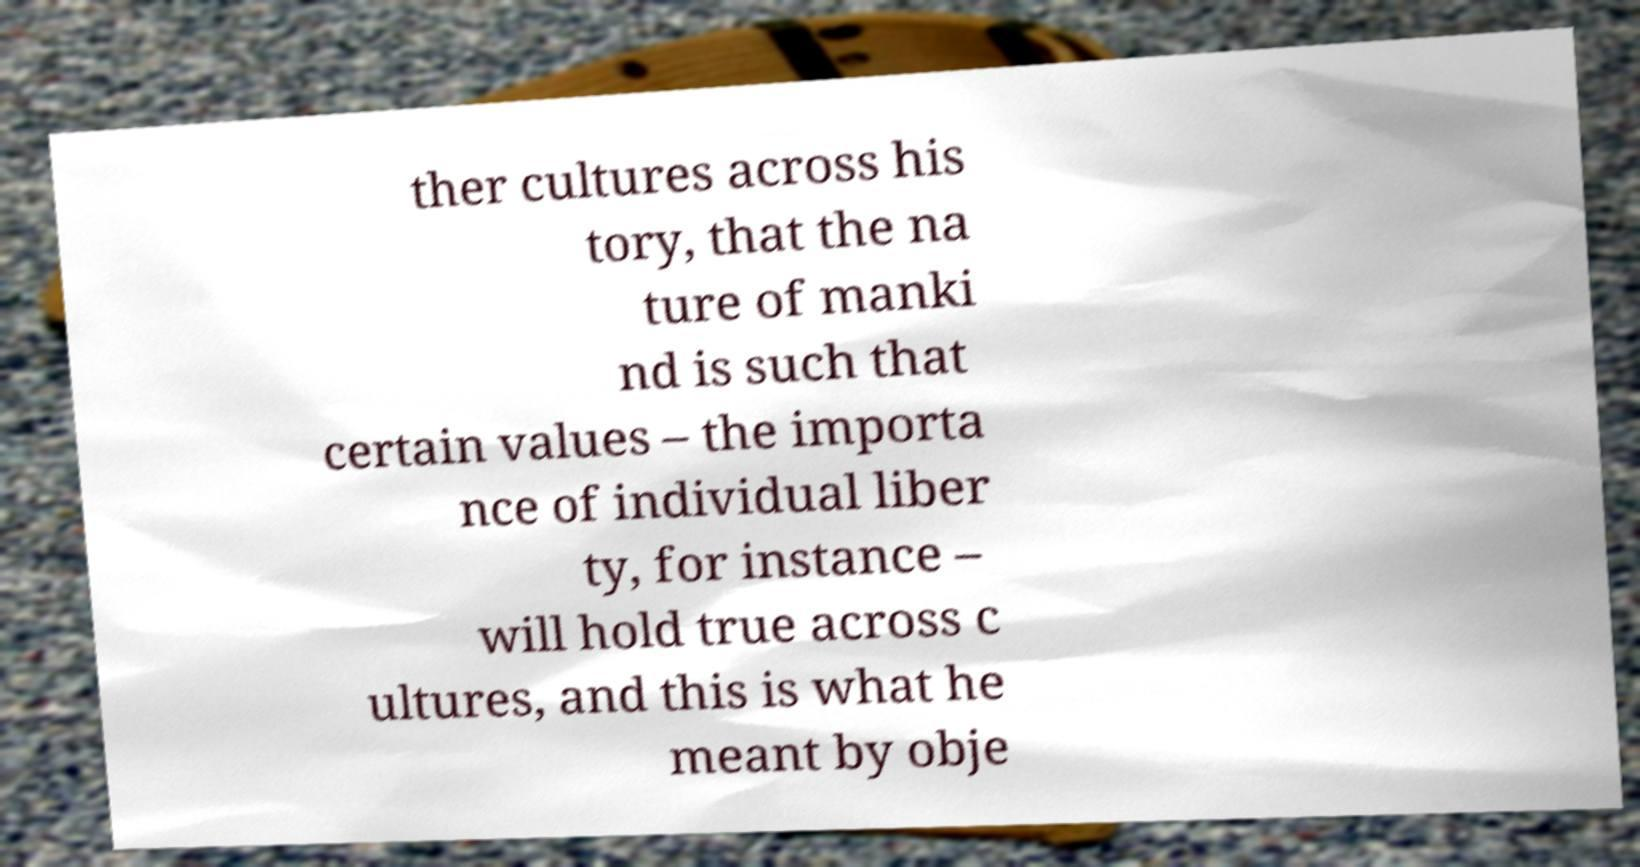What messages or text are displayed in this image? I need them in a readable, typed format. ther cultures across his tory, that the na ture of manki nd is such that certain values – the importa nce of individual liber ty, for instance – will hold true across c ultures, and this is what he meant by obje 